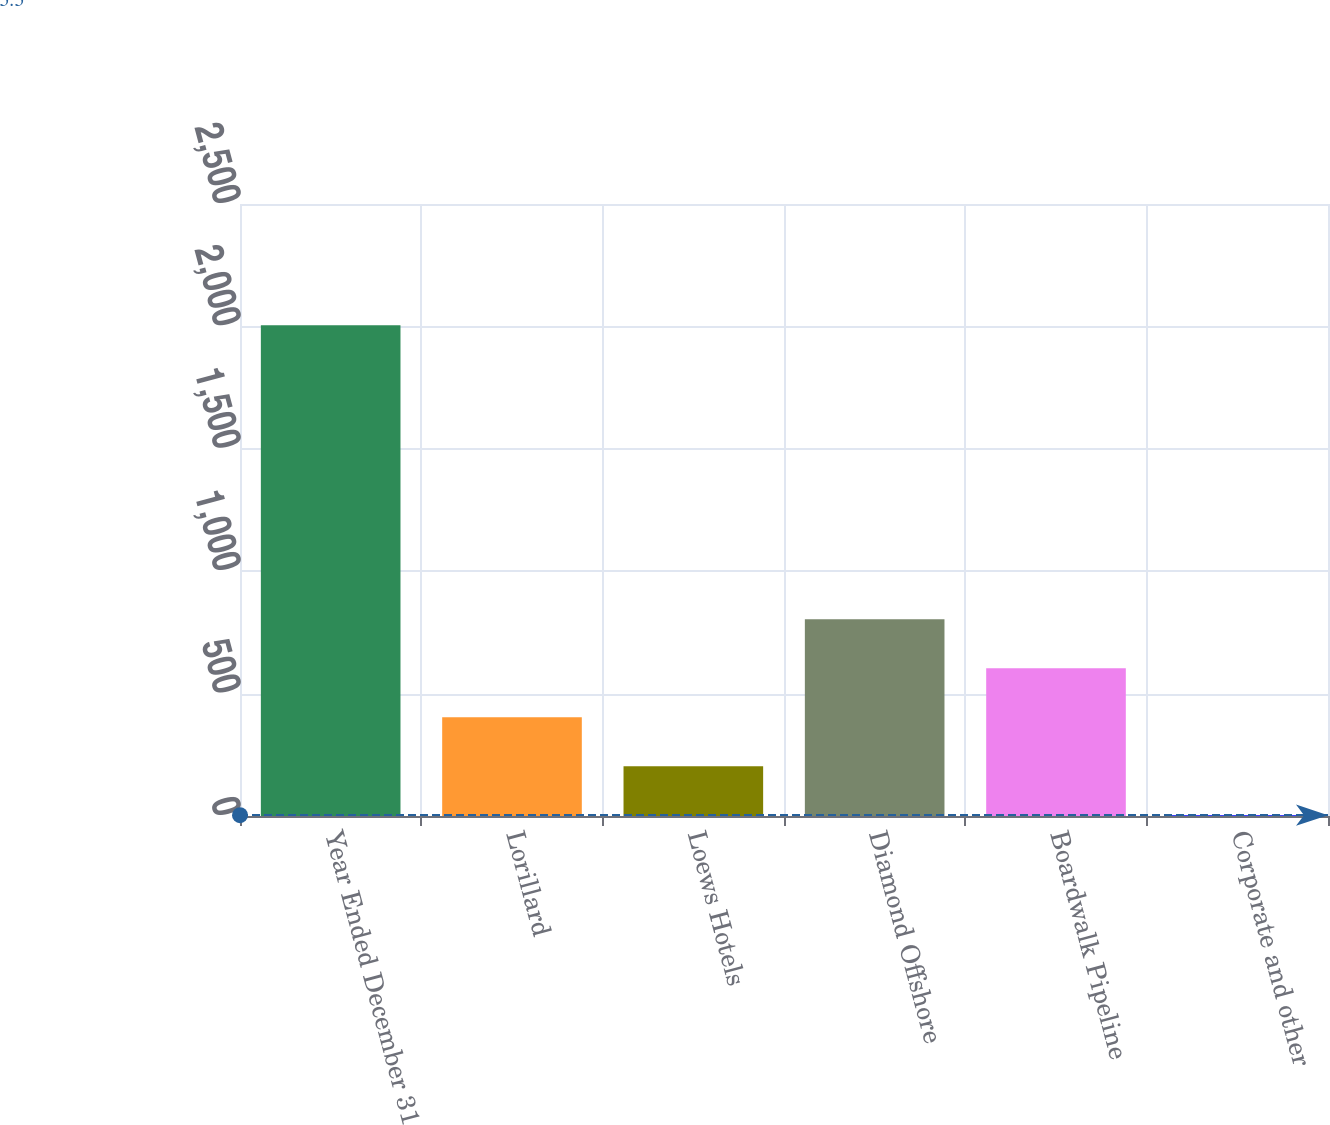<chart> <loc_0><loc_0><loc_500><loc_500><bar_chart><fcel>Year Ended December 31<fcel>Lorillard<fcel>Loews Hotels<fcel>Diamond Offshore<fcel>Boardwalk Pipeline<fcel>Corporate and other<nl><fcel>2005<fcel>403.64<fcel>203.47<fcel>803.98<fcel>603.81<fcel>3.3<nl></chart> 